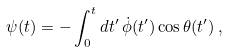Convert formula to latex. <formula><loc_0><loc_0><loc_500><loc_500>\psi ( t ) = - \int _ { 0 } ^ { t } d t ^ { \prime } \, \dot { \phi } ( t ^ { \prime } ) \cos \theta ( t ^ { \prime } ) \, ,</formula> 